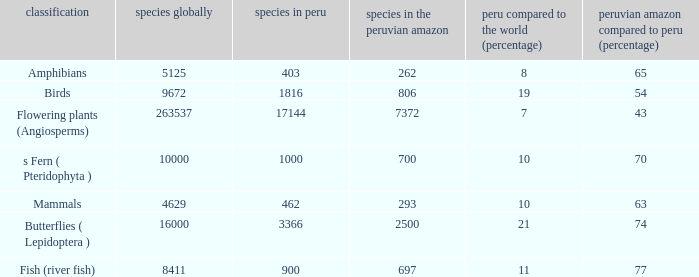What's the species in the world with peruvian amazon vs. peru (percent)  of 63 4629.0. 